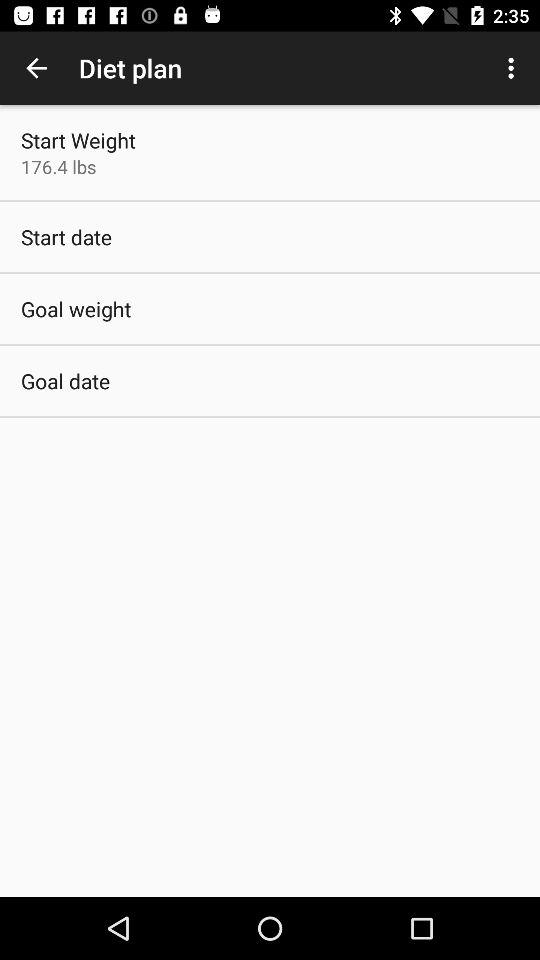What is the starting weight? The starting weight is 176.4 lbs. 